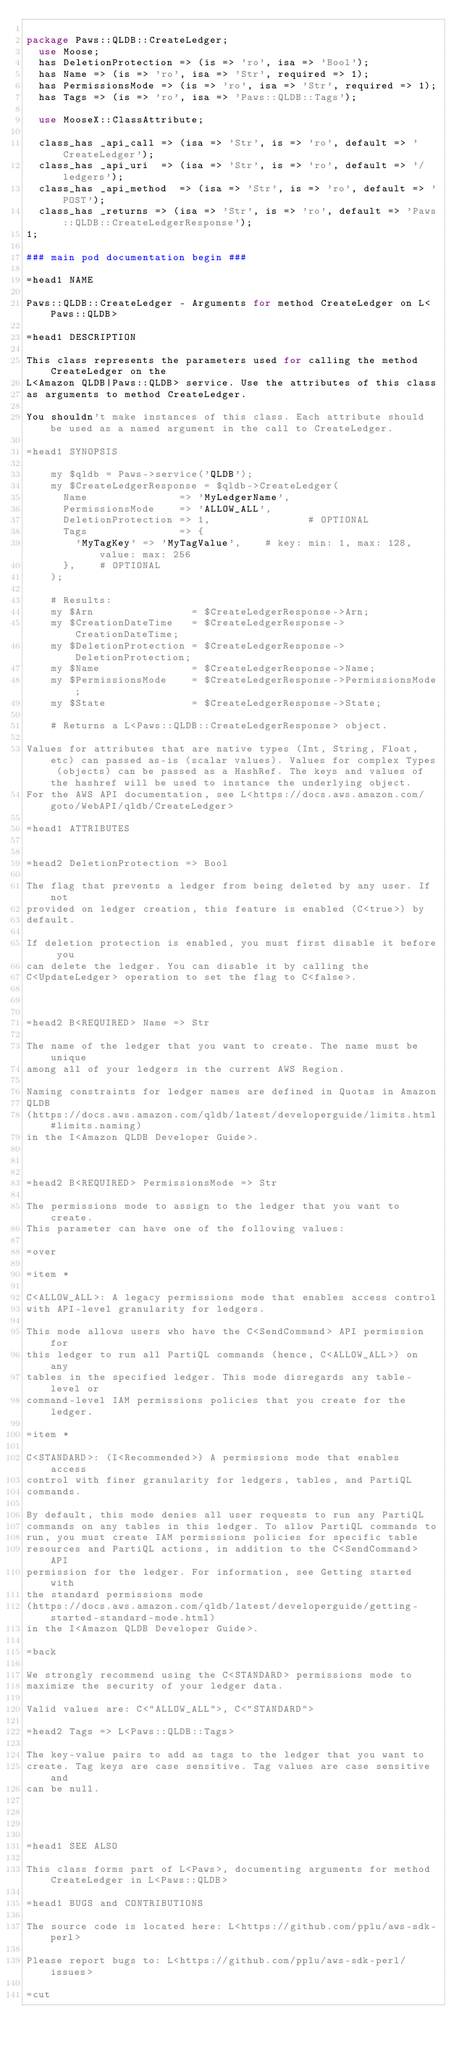<code> <loc_0><loc_0><loc_500><loc_500><_Perl_>
package Paws::QLDB::CreateLedger;
  use Moose;
  has DeletionProtection => (is => 'ro', isa => 'Bool');
  has Name => (is => 'ro', isa => 'Str', required => 1);
  has PermissionsMode => (is => 'ro', isa => 'Str', required => 1);
  has Tags => (is => 'ro', isa => 'Paws::QLDB::Tags');

  use MooseX::ClassAttribute;

  class_has _api_call => (isa => 'Str', is => 'ro', default => 'CreateLedger');
  class_has _api_uri  => (isa => 'Str', is => 'ro', default => '/ledgers');
  class_has _api_method  => (isa => 'Str', is => 'ro', default => 'POST');
  class_has _returns => (isa => 'Str', is => 'ro', default => 'Paws::QLDB::CreateLedgerResponse');
1;

### main pod documentation begin ###

=head1 NAME

Paws::QLDB::CreateLedger - Arguments for method CreateLedger on L<Paws::QLDB>

=head1 DESCRIPTION

This class represents the parameters used for calling the method CreateLedger on the
L<Amazon QLDB|Paws::QLDB> service. Use the attributes of this class
as arguments to method CreateLedger.

You shouldn't make instances of this class. Each attribute should be used as a named argument in the call to CreateLedger.

=head1 SYNOPSIS

    my $qldb = Paws->service('QLDB');
    my $CreateLedgerResponse = $qldb->CreateLedger(
      Name               => 'MyLedgerName',
      PermissionsMode    => 'ALLOW_ALL',
      DeletionProtection => 1,                # OPTIONAL
      Tags               => {
        'MyTagKey' => 'MyTagValue',    # key: min: 1, max: 128, value: max: 256
      },    # OPTIONAL
    );

    # Results:
    my $Arn                = $CreateLedgerResponse->Arn;
    my $CreationDateTime   = $CreateLedgerResponse->CreationDateTime;
    my $DeletionProtection = $CreateLedgerResponse->DeletionProtection;
    my $Name               = $CreateLedgerResponse->Name;
    my $PermissionsMode    = $CreateLedgerResponse->PermissionsMode;
    my $State              = $CreateLedgerResponse->State;

    # Returns a L<Paws::QLDB::CreateLedgerResponse> object.

Values for attributes that are native types (Int, String, Float, etc) can passed as-is (scalar values). Values for complex Types (objects) can be passed as a HashRef. The keys and values of the hashref will be used to instance the underlying object.
For the AWS API documentation, see L<https://docs.aws.amazon.com/goto/WebAPI/qldb/CreateLedger>

=head1 ATTRIBUTES


=head2 DeletionProtection => Bool

The flag that prevents a ledger from being deleted by any user. If not
provided on ledger creation, this feature is enabled (C<true>) by
default.

If deletion protection is enabled, you must first disable it before you
can delete the ledger. You can disable it by calling the
C<UpdateLedger> operation to set the flag to C<false>.



=head2 B<REQUIRED> Name => Str

The name of the ledger that you want to create. The name must be unique
among all of your ledgers in the current AWS Region.

Naming constraints for ledger names are defined in Quotas in Amazon
QLDB
(https://docs.aws.amazon.com/qldb/latest/developerguide/limits.html#limits.naming)
in the I<Amazon QLDB Developer Guide>.



=head2 B<REQUIRED> PermissionsMode => Str

The permissions mode to assign to the ledger that you want to create.
This parameter can have one of the following values:

=over

=item *

C<ALLOW_ALL>: A legacy permissions mode that enables access control
with API-level granularity for ledgers.

This mode allows users who have the C<SendCommand> API permission for
this ledger to run all PartiQL commands (hence, C<ALLOW_ALL>) on any
tables in the specified ledger. This mode disregards any table-level or
command-level IAM permissions policies that you create for the ledger.

=item *

C<STANDARD>: (I<Recommended>) A permissions mode that enables access
control with finer granularity for ledgers, tables, and PartiQL
commands.

By default, this mode denies all user requests to run any PartiQL
commands on any tables in this ledger. To allow PartiQL commands to
run, you must create IAM permissions policies for specific table
resources and PartiQL actions, in addition to the C<SendCommand> API
permission for the ledger. For information, see Getting started with
the standard permissions mode
(https://docs.aws.amazon.com/qldb/latest/developerguide/getting-started-standard-mode.html)
in the I<Amazon QLDB Developer Guide>.

=back

We strongly recommend using the C<STANDARD> permissions mode to
maximize the security of your ledger data.

Valid values are: C<"ALLOW_ALL">, C<"STANDARD">

=head2 Tags => L<Paws::QLDB::Tags>

The key-value pairs to add as tags to the ledger that you want to
create. Tag keys are case sensitive. Tag values are case sensitive and
can be null.




=head1 SEE ALSO

This class forms part of L<Paws>, documenting arguments for method CreateLedger in L<Paws::QLDB>

=head1 BUGS and CONTRIBUTIONS

The source code is located here: L<https://github.com/pplu/aws-sdk-perl>

Please report bugs to: L<https://github.com/pplu/aws-sdk-perl/issues>

=cut

</code> 